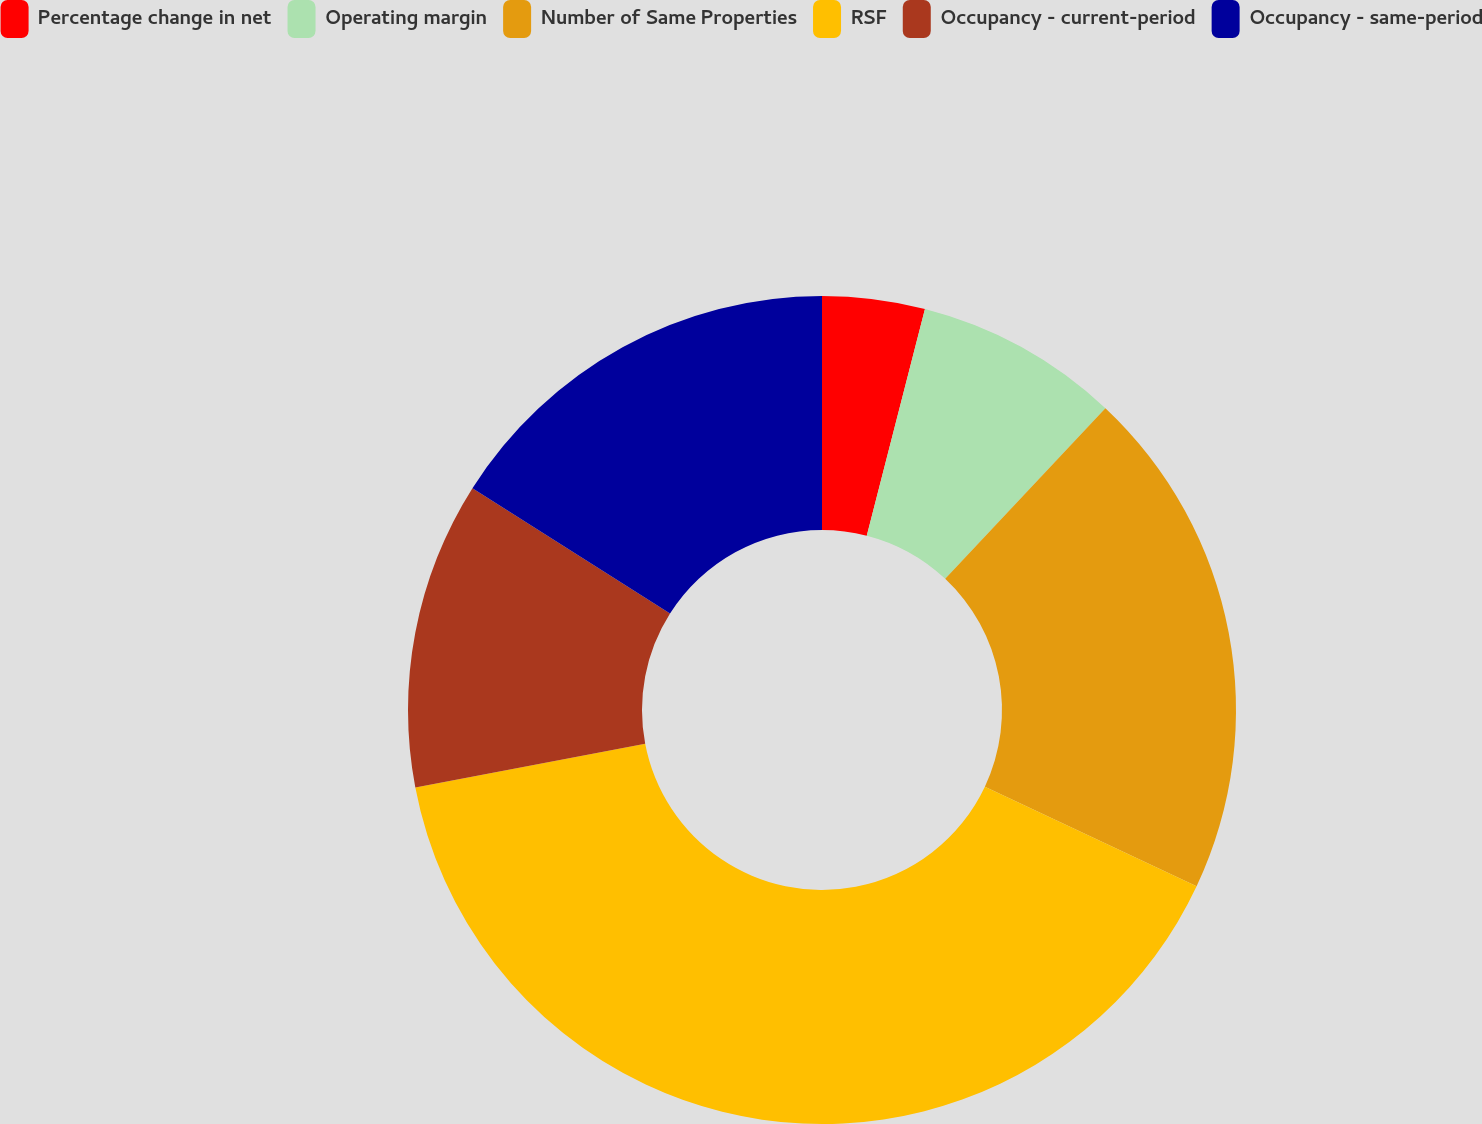<chart> <loc_0><loc_0><loc_500><loc_500><pie_chart><fcel>Percentage change in net<fcel>Operating margin<fcel>Number of Same Properties<fcel>RSF<fcel>Occupancy - current-period<fcel>Occupancy - same-period<nl><fcel>4.0%<fcel>8.0%<fcel>20.0%<fcel>40.0%<fcel>12.0%<fcel>16.0%<nl></chart> 